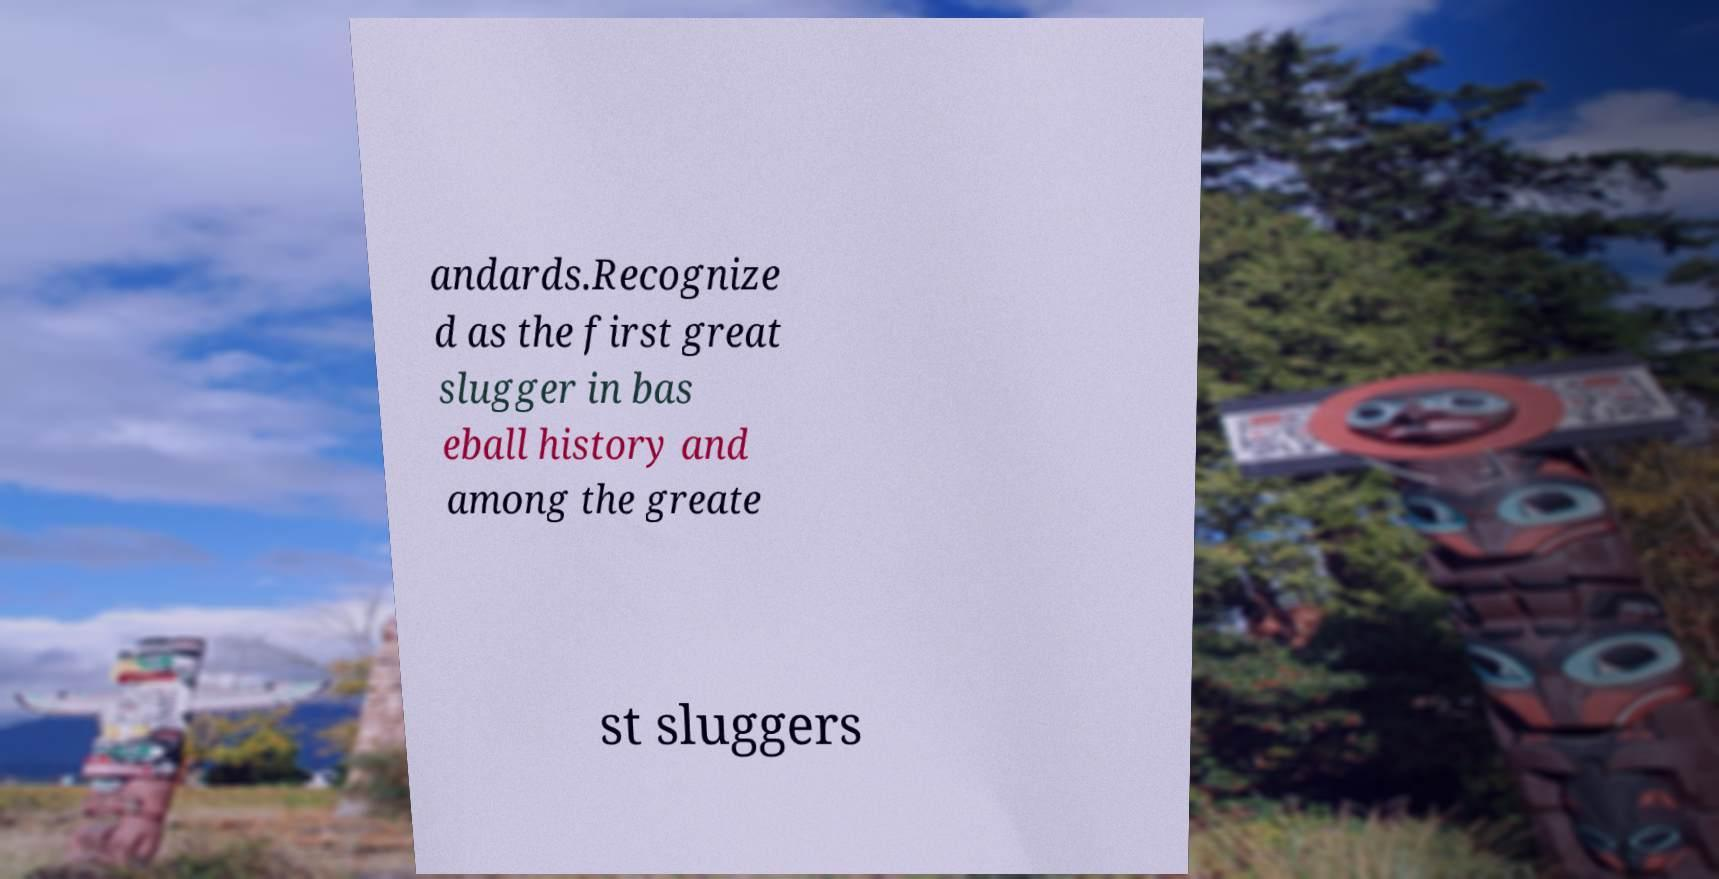Could you assist in decoding the text presented in this image and type it out clearly? andards.Recognize d as the first great slugger in bas eball history and among the greate st sluggers 